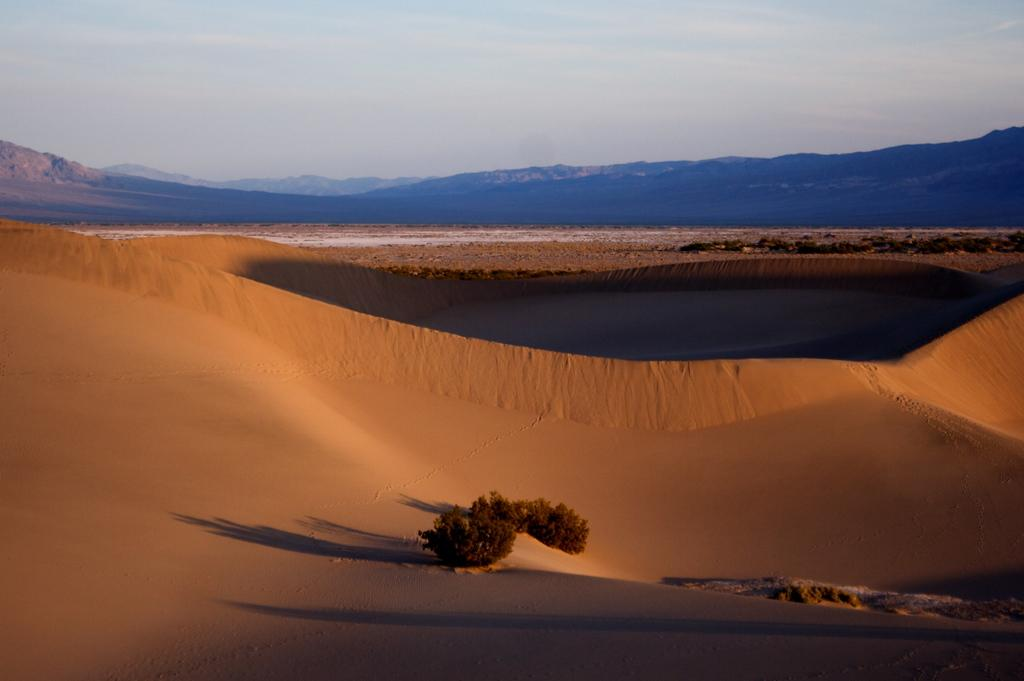What type of food is featured in the picture? There is a dessert in the picture. What natural elements can be seen in the picture? There are trees and hills in the picture. What part of the natural environment is visible in the background of the picture? The sky is visible in the background of the picture. Can you tell me how many chairs are placed near the dessert in the picture? There are no chairs present in the image; it only features a dessert, trees, hills, and the sky. Is there a bear visible in the picture? There is no bear present in the image. 